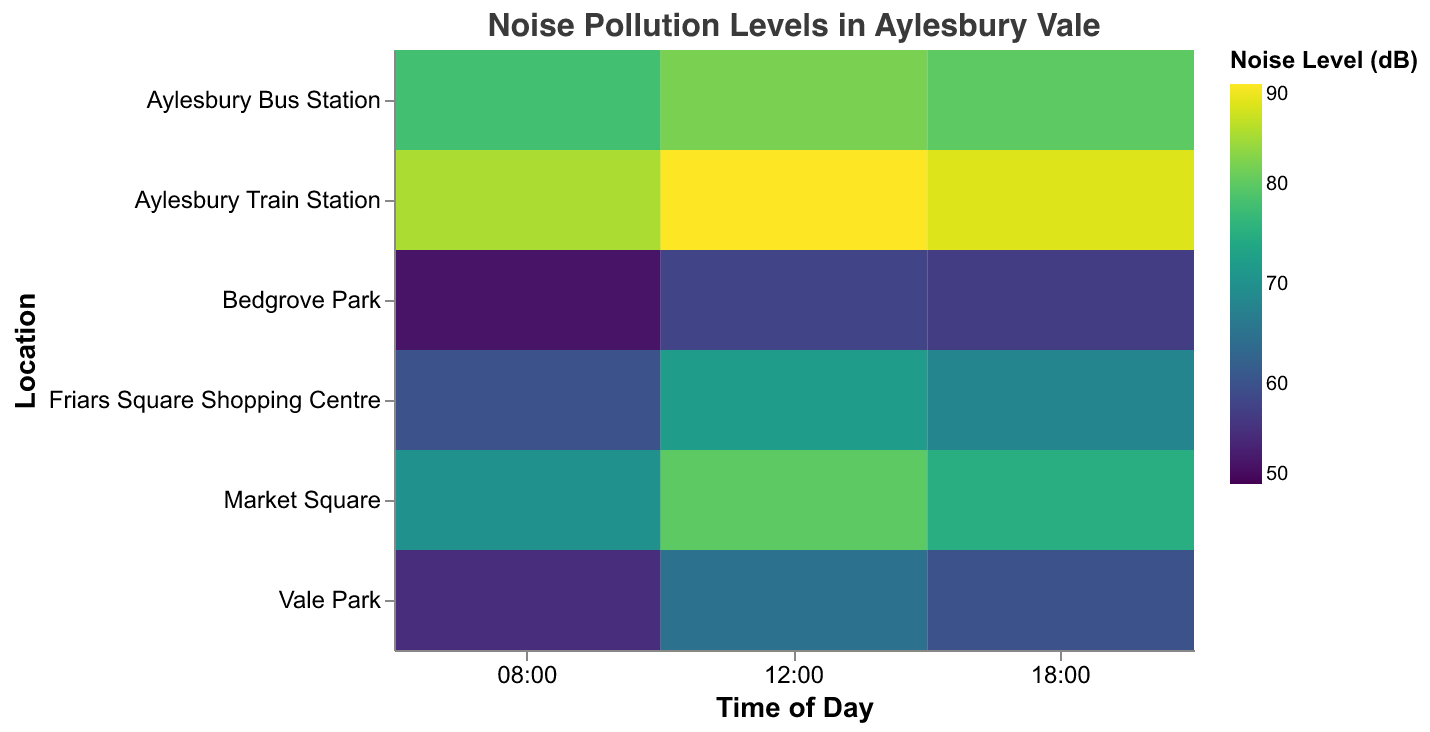What is the highest noise level recorded in Aylesbury Vale? The highest noise level can be found by identifying the data point with the maximum noise level (color with the highest intensity). The Aylesbury Train Station at 12:00 records the highest noise level of 90 dB.
Answer: 90 dB Which location has the lowest noise level at 08:00? Examine the noise levels at 08:00 for various locations and identify the lowest value. Bedgrove Park has the lowest noise level at 08:00, which is 52 dB.
Answer: Bedgrove Park What is the noise level range at Market Square throughout the day? Identify the minimum and maximum noise levels for Market Square at different times. The noise levels at Market Square are 70 dB at 08:00, 80 dB at 12:00, and 75 dB at 18:00. The range is from 70 dB to 80 dB.
Answer: 70 dB to 80 dB How does the noise level at Aylesbury Bus Station at 18:00 compare to that at Vale Park at the same time? Check the noise levels at 18:00 for both locations. Aylesbury Bus Station has a noise level of 80 dB, while Vale Park has a noise level of 60 dB. 80 dB is higher than 60 dB.
Answer: Higher During which time period does Friars Square Shopping Centre have the highest noise level? Identify the noise levels at Friars Square Shopping Centre at different times. The noise levels are 60 dB at 08:00, 72 dB at 12:00, and 68 dB at 18:00. The highest noise level is at 12:00.
Answer: 12:00 Compare the average noise levels of Bedgrove Park and Vale Park. Which one is noisier on average? Calculate the average noise level for both parks. Bedgrove Park: (52+58+57)/3 = 55.67 dB. Vale Park: (55+65+60)/3 = 60 dB. Vale Park is noisier on average.
Answer: Vale Park What are the noise levels at Aylesbury Train Station during the day? Note the noise levels recorded at different times during the day. The noise levels at Aylesbury Train Station are 85 dB at 08:00, 90 dB at 12:00, and 88 dB at 18:00.
Answer: 85 dB, 90 dB, 88 dB At what time does Aylesbury Bus Station have its minimum noise level? Look at the noise levels at different times for Aylesbury Bus Station. The noise levels are 78 dB at 08:00, 82 dB at 12:00, and 80 dB at 18:00. The minimum noise level is at 08:00.
Answer: 08:00 